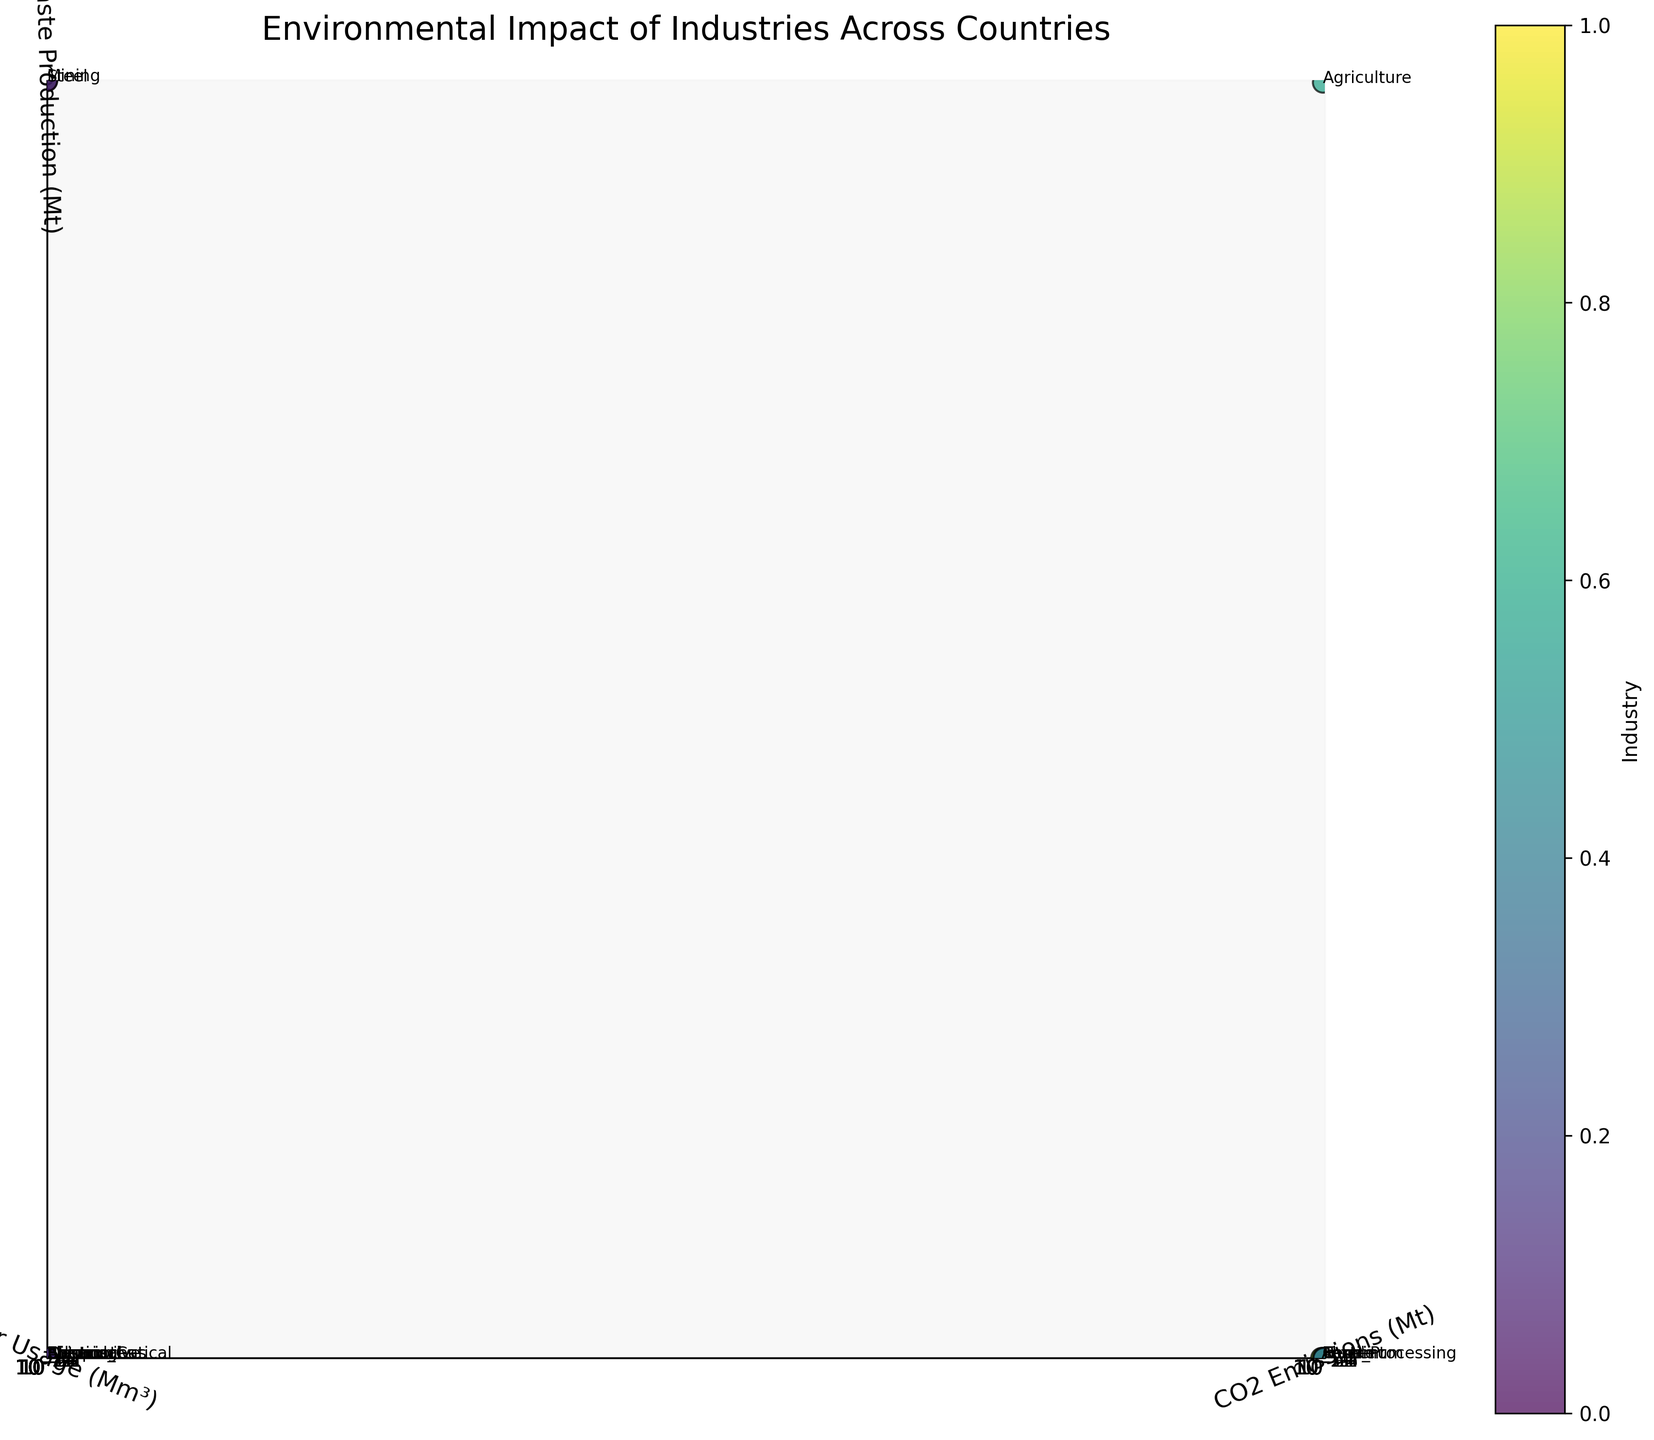What's the title of the figure? The title is usually displayed at the top of the figure. In this case, the title is shown clearly as "Environmental Impact of Industries Across Countries."
Answer: Environmental Impact of Industries Across Countries Which axis represents water usage? The axis labels indicate what each axis represents. Here, the y-axis label is "Water Usage (Mm³)," meaning the y-axis represents water usage.
Answer: y-axis How many industries are plotted in the figure? You can count the number of data points labelled with different industries. The plot has one label for each industry, totaling 15 industries.
Answer: 15 Which industry has the highest CO2 emissions? The highest CO2 emissions can be identified by finding the data point with the maximum x-value. According to the data, the Steel industry has the highest CO2 emissions at 1750 Mt.
Answer: Steel What industry is represented by the data point with the lowest waste production? The lowest z-value on the plot corresponds to the industry with the least waste production. The Shipping industry, with a waste production of 8 Mt, has the lowest value.
Answer: Shipping Which industry uses more water, Food Processing or Aluminum? By comparing the y-values of both data points, you’ll see that Food Processing uses 1100 Mm³, while Aluminum uses 900 Mm³.
Answer: Food Processing What's the combined waste production of the Mining and Textile industries? Look at the z-values for both industries: Mining (280 Mt) and Textile (22 Mt). Sum these values: 280 + 22 = 302 Mt.
Answer: 302 Mt Between Pharmaceuticals and Cement industries, which one produces more CO2? Compare the x-values: The Pharmaceutical industry emits 30 Mt, while the Cement industry emits 95 Mt. The Cement industry has higher CO2 emissions.
Answer: Cement Which industry in Canada is plotted, and what’s its water usage? The label "Canada" identifies the country, with "Paper" being the corresponding industry. The y-value for this data point shows that water usage is 1600 Mm³.
Answer: Paper, 1600 Mm³ If the environmental impact is considered as the sum of CO2 emissions, water usage, and waste production, which industry has the least environmental impact? Calculate the sum for each industry, then identify the smallest:
- Steel: 1750 + 14000 + 400 = 16150
- Oil and Gas: 980 + 5600 + 180 = 6760
- Automotive: 120 + 450 + 35 = 605
- Electronics: 85 + 380 + 28 = 493
- Chemical: 310 + 2200 + 95 = 2605
- Textile: 65 + 1800 + 22 = 1887
- Mining: 420 + 3100 + 280 = 3800
- Paper: 55 + 1600 + 18 = 1673
- Agriculture: 470 + 4200 + 150 = 4820
- Cement: 95 + 850 + 40 = 985
- Pharmaceuticals: 30 + 220 + 12 = 262
- Food Processing: 75 + 1100 + 25 = 1200
- Aluminum: 110 + 900 + 30 = 1040
- Plastics: 45 + 320 + 15 = 380
- Shipping: 85 + 180 + 8 = 273
The Pharmaceuticals industry has the least environmental impact.
Answer: Pharmaceuticals 